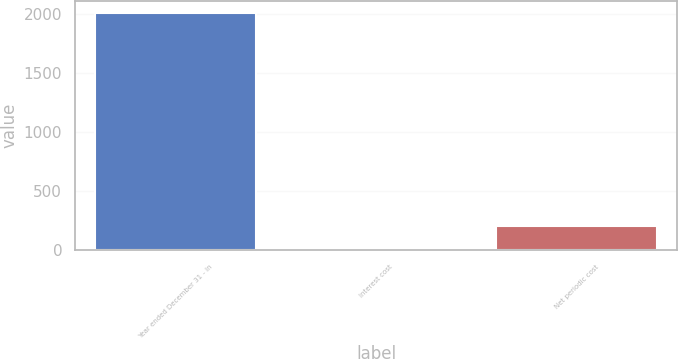Convert chart to OTSL. <chart><loc_0><loc_0><loc_500><loc_500><bar_chart><fcel>Year ended December 31 - in<fcel>Interest cost<fcel>Net periodic cost<nl><fcel>2008<fcel>6<fcel>206.2<nl></chart> 